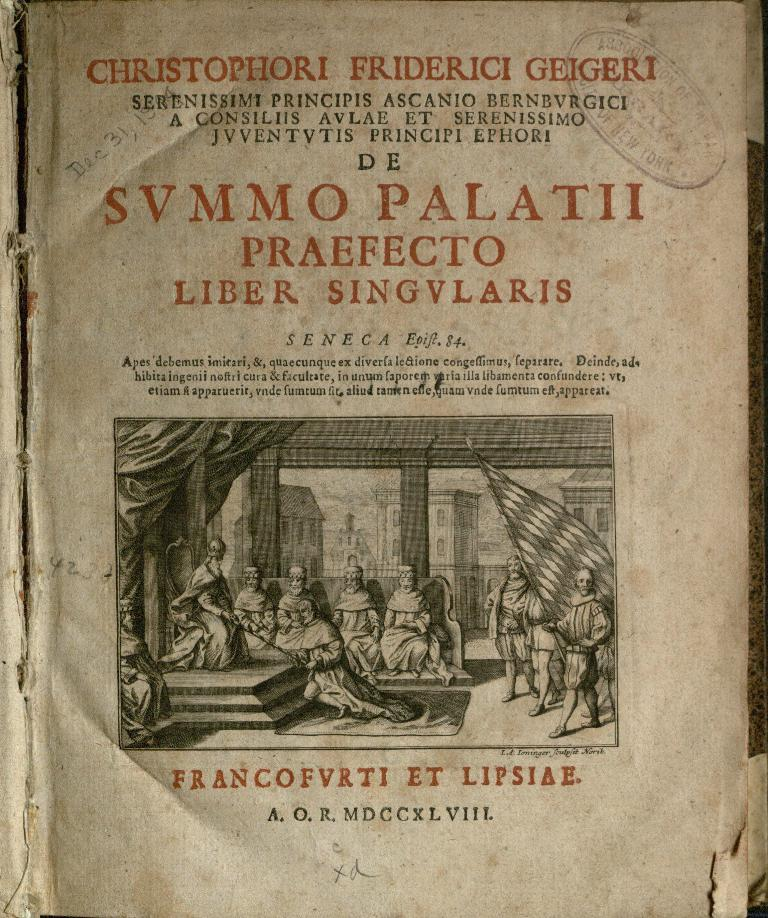<image>
Write a terse but informative summary of the picture. An ancient looking book with curled edges titled SVMMO PALATII. 